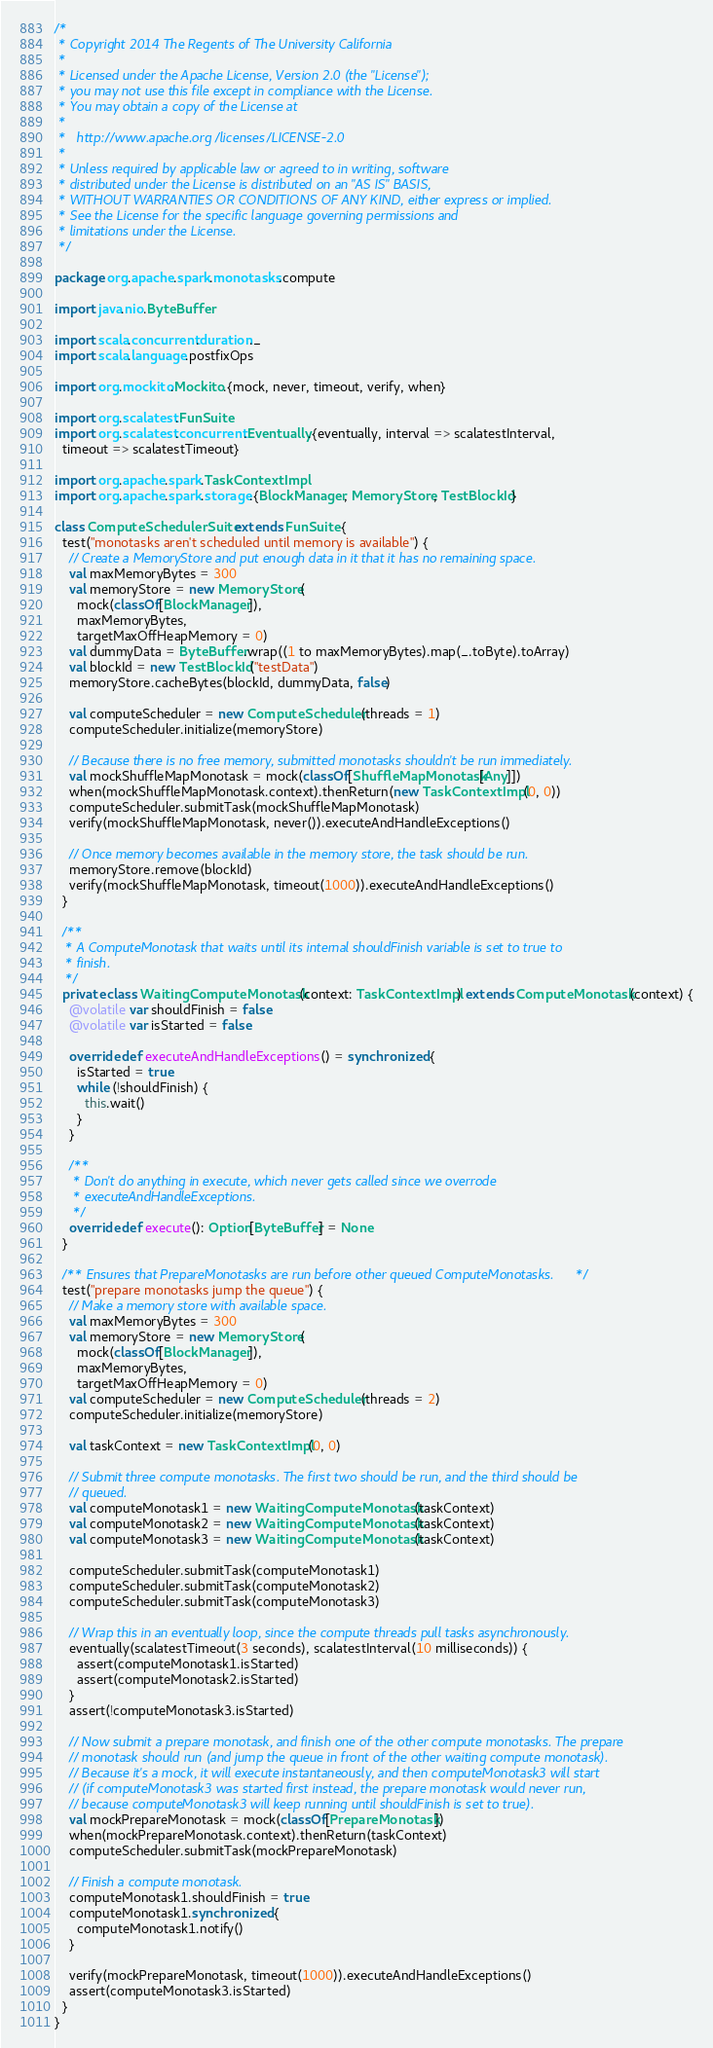<code> <loc_0><loc_0><loc_500><loc_500><_Scala_>/*
 * Copyright 2014 The Regents of The University California
 *
 * Licensed under the Apache License, Version 2.0 (the "License");
 * you may not use this file except in compliance with the License.
 * You may obtain a copy of the License at
 *
 *   http://www.apache.org/licenses/LICENSE-2.0
 *
 * Unless required by applicable law or agreed to in writing, software
 * distributed under the License is distributed on an "AS IS" BASIS,
 * WITHOUT WARRANTIES OR CONDITIONS OF ANY KIND, either express or implied.
 * See the License for the specific language governing permissions and
 * limitations under the License.
 */

package org.apache.spark.monotasks.compute

import java.nio.ByteBuffer

import scala.concurrent.duration._
import scala.language.postfixOps

import org.mockito.Mockito.{mock, never, timeout, verify, when}

import org.scalatest.FunSuite
import org.scalatest.concurrent.Eventually.{eventually, interval => scalatestInterval,
  timeout => scalatestTimeout}

import org.apache.spark.TaskContextImpl
import org.apache.spark.storage.{BlockManager, MemoryStore, TestBlockId}

class ComputeSchedulerSuite extends FunSuite {
  test("monotasks aren't scheduled until memory is available") {
    // Create a MemoryStore and put enough data in it that it has no remaining space.
    val maxMemoryBytes = 300
    val memoryStore = new MemoryStore(
      mock(classOf[BlockManager]),
      maxMemoryBytes,
      targetMaxOffHeapMemory = 0)
    val dummyData = ByteBuffer.wrap((1 to maxMemoryBytes).map(_.toByte).toArray)
    val blockId = new TestBlockId("testData")
    memoryStore.cacheBytes(blockId, dummyData, false)

    val computeScheduler = new ComputeScheduler(threads = 1)
    computeScheduler.initialize(memoryStore)

    // Because there is no free memory, submitted monotasks shouldn't be run immediately.
    val mockShuffleMapMonotask = mock(classOf[ShuffleMapMonotask[Any]])
    when(mockShuffleMapMonotask.context).thenReturn(new TaskContextImpl(0, 0))
    computeScheduler.submitTask(mockShuffleMapMonotask)
    verify(mockShuffleMapMonotask, never()).executeAndHandleExceptions()

    // Once memory becomes available in the memory store, the task should be run.
    memoryStore.remove(blockId)
    verify(mockShuffleMapMonotask, timeout(1000)).executeAndHandleExceptions()
  }

  /**
   * A ComputeMonotask that waits until its internal shouldFinish variable is set to true to
   * finish.
   */
  private class WaitingComputeMonotask(context: TaskContextImpl) extends ComputeMonotask(context) {
    @volatile var shouldFinish = false
    @volatile var isStarted = false

    override def executeAndHandleExceptions() = synchronized {
      isStarted = true
      while (!shouldFinish) {
        this.wait()
      }
    }

    /**
     * Don't do anything in execute, which never gets called since we overrode
     * executeAndHandleExceptions.
     */
    override def execute(): Option[ByteBuffer] = None
  }

  /** Ensures that PrepareMonotasks are run before other queued ComputeMonotasks. */
  test("prepare monotasks jump the queue") {
    // Make a memory store with available space.
    val maxMemoryBytes = 300
    val memoryStore = new MemoryStore(
      mock(classOf[BlockManager]),
      maxMemoryBytes,
      targetMaxOffHeapMemory = 0)
    val computeScheduler = new ComputeScheduler(threads = 2)
    computeScheduler.initialize(memoryStore)

    val taskContext = new TaskContextImpl(0, 0)

    // Submit three compute monotasks. The first two should be run, and the third should be
    // queued.
    val computeMonotask1 = new WaitingComputeMonotask(taskContext)
    val computeMonotask2 = new WaitingComputeMonotask(taskContext)
    val computeMonotask3 = new WaitingComputeMonotask(taskContext)

    computeScheduler.submitTask(computeMonotask1)
    computeScheduler.submitTask(computeMonotask2)
    computeScheduler.submitTask(computeMonotask3)

    // Wrap this in an eventually loop, since the compute threads pull tasks asynchronously.
    eventually(scalatestTimeout(3 seconds), scalatestInterval(10 milliseconds)) {
      assert(computeMonotask1.isStarted)
      assert(computeMonotask2.isStarted)
    }
    assert(!computeMonotask3.isStarted)

    // Now submit a prepare monotask, and finish one of the other compute monotasks. The prepare
    // monotask should run (and jump the queue in front of the other waiting compute monotask).
    // Because it's a mock, it will execute instantaneously, and then computeMonotask3 will start
    // (if computeMonotask3 was started first instead, the prepare monotask would never run,
    // because computeMonotask3 will keep running until shouldFinish is set to true).
    val mockPrepareMonotask = mock(classOf[PrepareMonotask])
    when(mockPrepareMonotask.context).thenReturn(taskContext)
    computeScheduler.submitTask(mockPrepareMonotask)

    // Finish a compute monotask.
    computeMonotask1.shouldFinish = true
    computeMonotask1.synchronized {
      computeMonotask1.notify()
    }

    verify(mockPrepareMonotask, timeout(1000)).executeAndHandleExceptions()
    assert(computeMonotask3.isStarted)
  }
}
</code> 